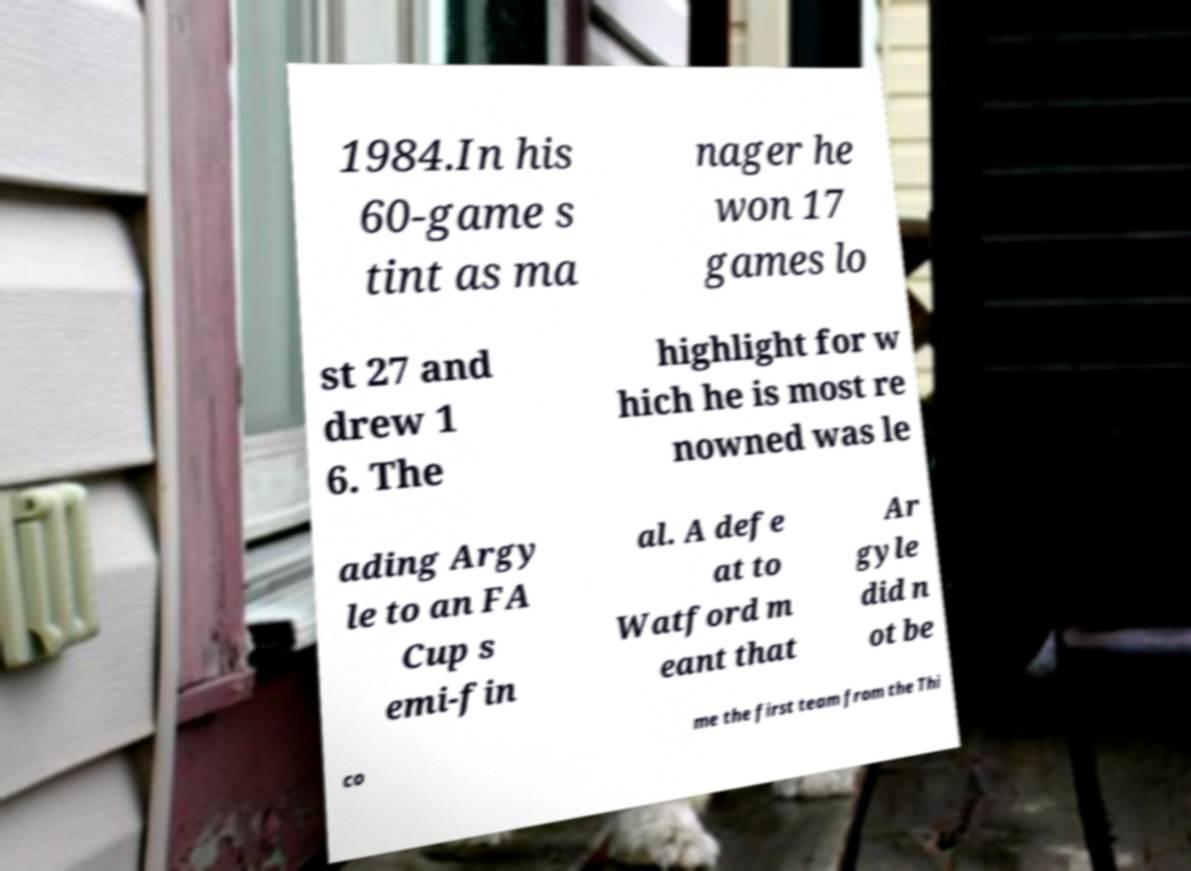What messages or text are displayed in this image? I need them in a readable, typed format. 1984.In his 60-game s tint as ma nager he won 17 games lo st 27 and drew 1 6. The highlight for w hich he is most re nowned was le ading Argy le to an FA Cup s emi-fin al. A defe at to Watford m eant that Ar gyle did n ot be co me the first team from the Thi 